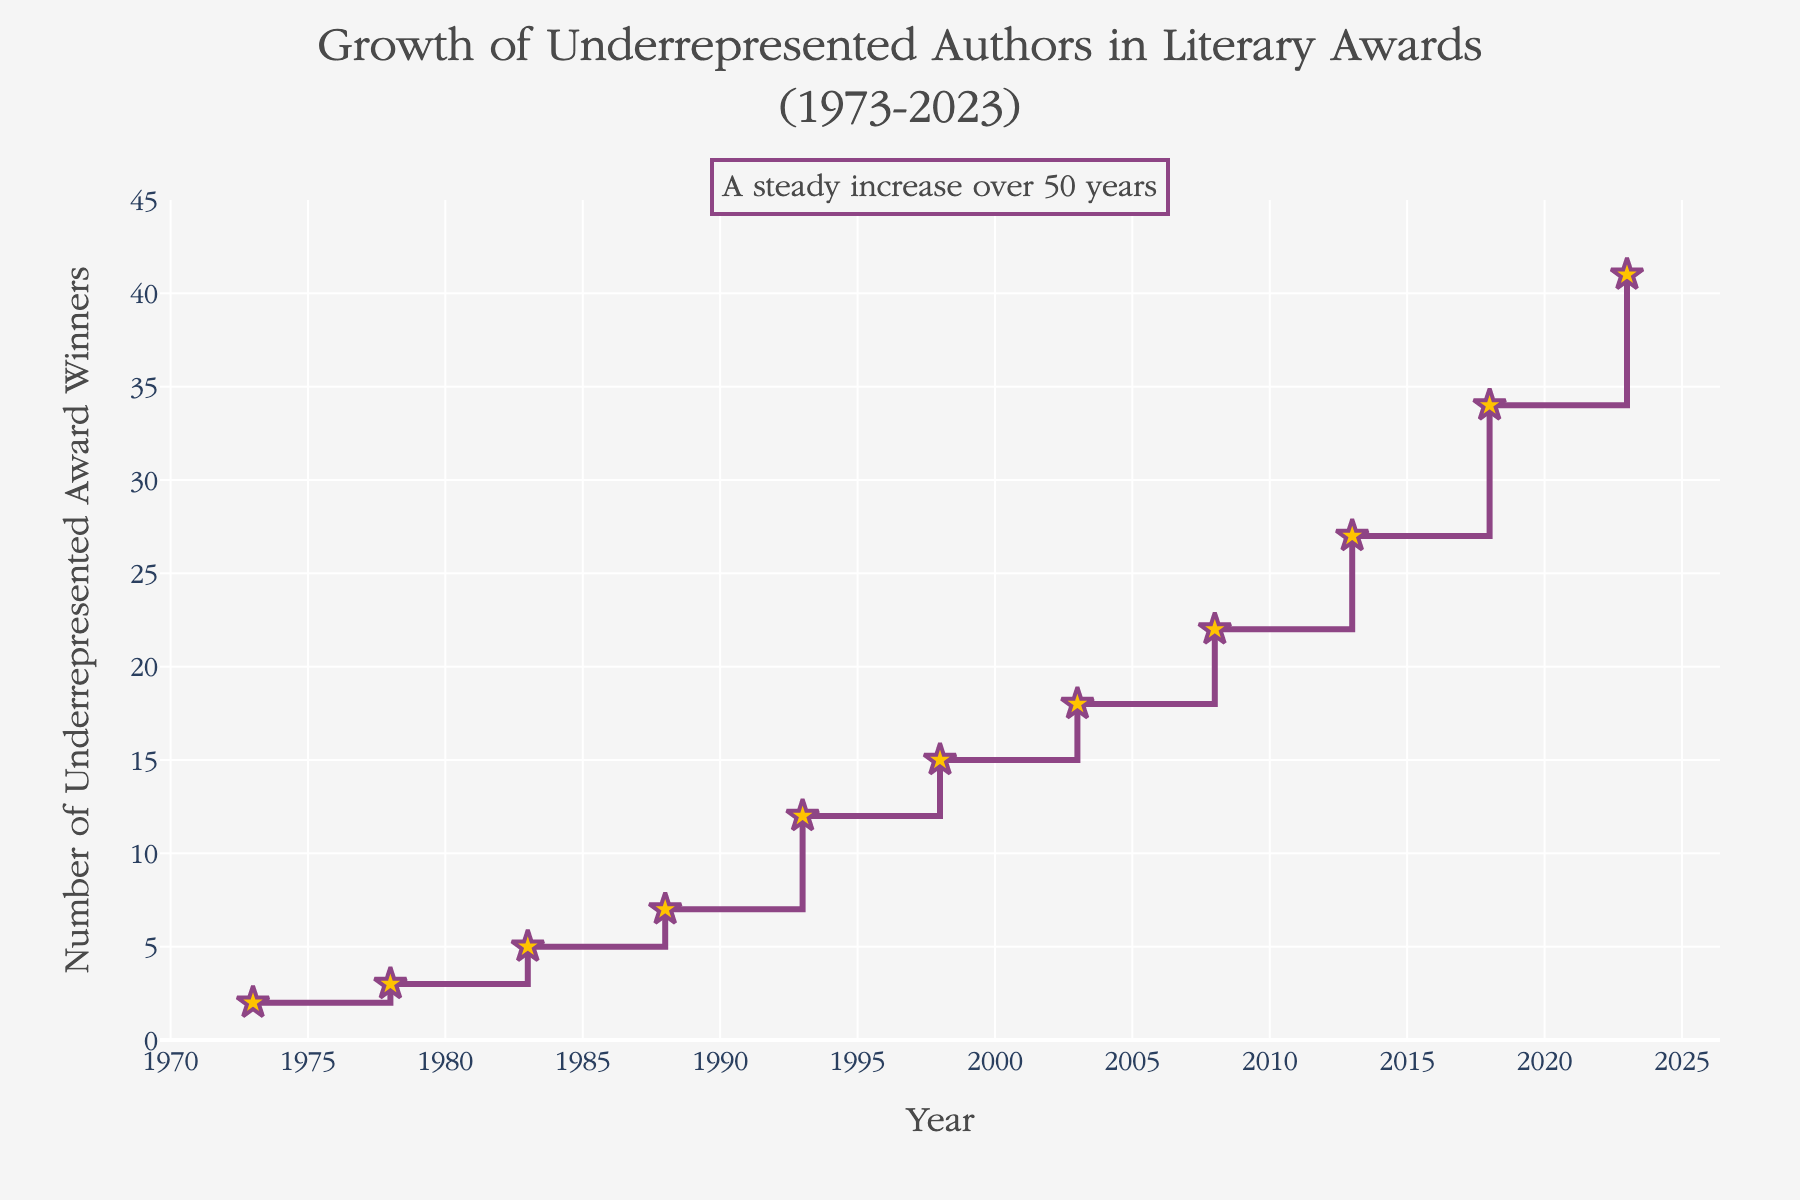What is the title of the figure? The title of the figure is located at the top center of the plot.
Answer: "Growth of Underrepresented Authors in Literary Awards (1973-2023)" How many underrepresented authors won awards in 1993? On the x-axis, locate the year 1993. Then, read the corresponding value on the y-axis.
Answer: 12 Which year saw the highest number of underrepresented award winners? Examine the y-axis values for the maximum number. The corresponding x-axis value (year) represents the highest number.
Answer: 2023 What was the increase in the number of underrepresented award winners from 1973 to 2023? Refer to the y-axis values for the years 1973 and 2023. Calculate the difference (41 - 2 = 39).
Answer: 39 What is the pattern depicted in the figure? Observe the overall trend in the figure, noting the annotations and the direction of the plotted line.
Answer: A steady increase over 50 years How many times does the number of underrepresented award winners cross the 20 mark? Identify the years where the y-axis value exceeds 20 (2008, 2013, 2018, 2023). Count these instances.
Answer: 4 What is the total number of underrepresented award winners between 1973 and 2023? Sum the y-axis values: 2 + 3 + 5 + 7 + 12 + 15 + 18 + 22 + 27 + 34 + 41 = 186
Answer: 186 In which 5-year period did the number of underrepresented award winners increase the most? Calculate the increase for each 5-year period: 1993-1998 (15-12=3), 1998-2003 (18-15=3), 2003-2008 (22-18=4), 2008-2013 (27-22=5), 2013-2018 (34-27=7), 2018-2023 (41-34=7). The maximum increase is 7.
Answer: 2013-2018 and 2018-2023 What was the average number of underrepresented award winners per decade from 1973 to 2023? Calculate the sum for each decade, then divide by the number of years: 1973-1983 (2+3+5=10, 10/3≈3.33), 1983-1993 (5+7+12=24, 24/3=8), 1993-2003 (12+15+18=45, 45/3=15), 2003-2013 (18+22+27=67, 67/3≈22.33), 2013-2023 (27+34+41=102, 102/3=34). Determine the average: (3.33+8+15+22.33+34) / 5 ≈ 16.53.
Answer: ≈ 16.53 